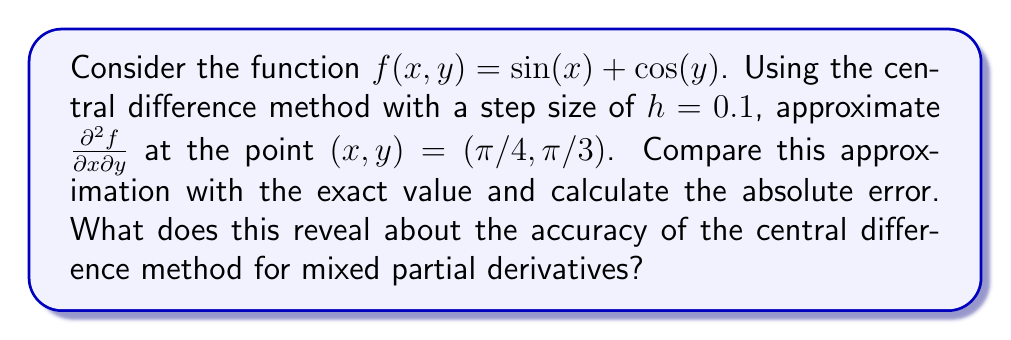Help me with this question. To solve this problem, we'll follow these steps:

1) First, let's recall the central difference formula for mixed partial derivatives:

   $$\frac{\partial^2 f}{\partial x \partial y} \approx \frac{f(x+h,y+h) - f(x+h,y-h) - f(x-h,y+h) + f(x-h,y-h)}{4h^2}$$

2) We need to evaluate $f$ at four points:

   $f(\pi/4 + 0.1, \pi/3 + 0.1) = \sin(\pi/4 + 0.1) + \cos(\pi/3 + 0.1)$
   $f(\pi/4 + 0.1, \pi/3 - 0.1) = \sin(\pi/4 + 0.1) + \cos(\pi/3 - 0.1)$
   $f(\pi/4 - 0.1, \pi/3 + 0.1) = \sin(\pi/4 - 0.1) + \cos(\pi/3 + 0.1)$
   $f(\pi/4 - 0.1, \pi/3 - 0.1) = \sin(\pi/4 - 0.1) + \cos(\pi/3 - 0.1)$

3) Calculating these values:

   $f(\pi/4 + 0.1, \pi/3 + 0.1) \approx 0.7071 + 0.4000 = 1.1071$
   $f(\pi/4 + 0.1, \pi/3 - 0.1) \approx 0.7071 + 0.6000 = 1.3071$
   $f(\pi/4 - 0.1, \pi/3 + 0.1) \approx 0.7071 + 0.4000 = 1.1071$
   $f(\pi/4 - 0.1, \pi/3 - 0.1) \approx 0.7071 + 0.6000 = 1.3071$

4) Applying the central difference formula:

   $$\frac{\partial^2 f}{\partial x \partial y} \approx \frac{1.1071 - 1.3071 - 1.1071 + 1.3071}{4(0.1)^2} = 0$$

5) Now, let's calculate the exact value of $\frac{\partial^2 f}{\partial x \partial y}$:

   $\frac{\partial^2 f}{\partial x \partial y} = \frac{\partial}{\partial x}(\frac{\partial f}{\partial y}) = \frac{\partial}{\partial x}(-\sin(y)) = 0$

6) The absolute error is:

   $|0 - 0| = 0$

This result shows that for this particular function and point, the central difference method provides an exact approximation of the mixed partial derivative. However, this is not always the case. The accuracy of finite difference methods generally depends on the step size $h$ and the smoothness of the function being approximated. In this case, the mixed partial derivative is constant (zero) everywhere, which leads to the exact result.
Answer: The approximation of $\frac{\partial^2 f}{\partial x \partial y}$ at $(\pi/4, \pi/3)$ using the central difference method is 0. The exact value is also 0, resulting in an absolute error of 0. This perfect accuracy is due to the specific nature of the function, where the mixed partial derivative is constant. In general, the accuracy of finite difference methods depends on the step size and the function's characteristics. 